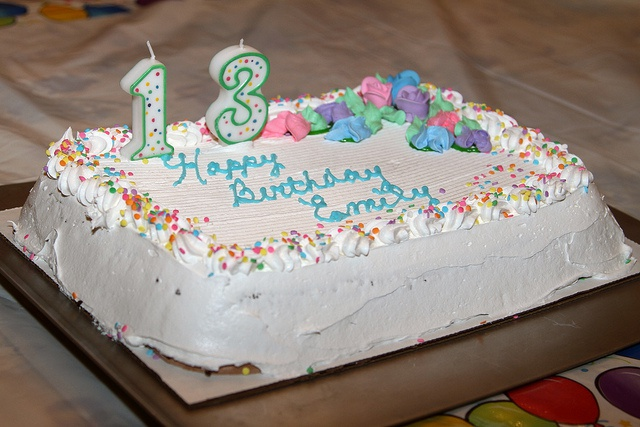Describe the objects in this image and their specific colors. I can see cake in maroon, lightgray, darkgray, and pink tones and dining table in maroon and gray tones in this image. 